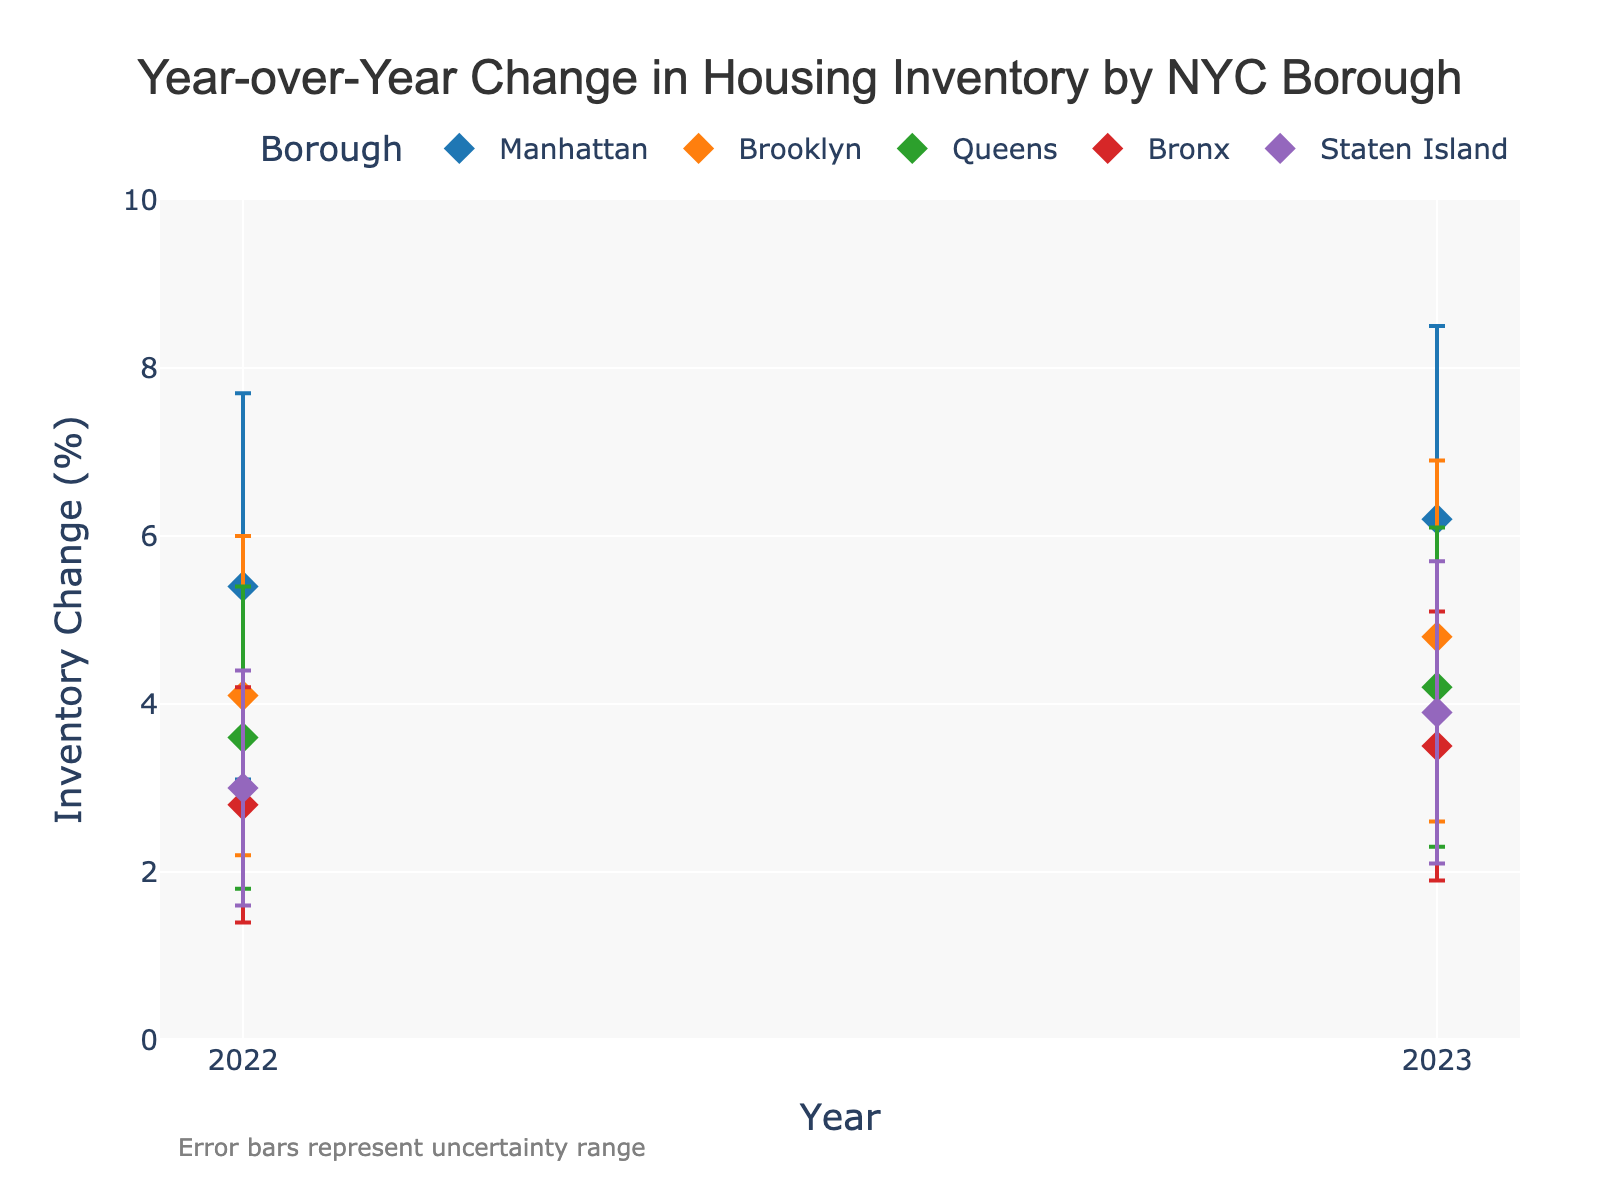What is the title of the figure? The title is located at the top of the figure. It is usually larger and bolded compared to other text elements.
Answer: Year-over-Year Change in Housing Inventory by NYC Borough Which borough had the highest mean inventory change in 2023? By looking at the y-axis values for the year 2023 markers, find the data point with the highest value.
Answer: Manhattan What is the range of inventory change for Queens in 2022? Identify the lower and upper bounds for Queens in 2022 from the error bars. The range is the difference between the upper and lower bounds.
Answer: 3.6 - 5.4 How did the mean inventory change for Brooklyn compare between 2022 and 2023? Look at the mean inventory change values for Brooklyn in both years and compare them.
Answer: Increased from 4.1 to 4.8 Which borough had the smallest error range in 2023? Calculate the error range (difference between upper and lower bounds) for each borough in 2023 and find the smallest one. For example, Bronx: 5.1 - 1.9 = 3.2, and so on for each borough.
Answer: Bronx What is the difference in mean inventory change between the Bronx and Staten Island in 2022? Compare the mean inventory change values from the dot representing the Bronx with the dot representing Staten Island in 2022. Subtract the value for Staten Island from that of the Bronx.
Answer: 2.8 - 3.0 = -0.2 Which borough shows the most significant increase in mean inventory change from 2022 to 2023? Calculate the difference in mean inventory change from 2022 to 2023 for each borough and identify the largest increase. For Manhattan: 6.2 - 5.4 = 0.8, for Brooklyn: 4.8 - 4.1 = 0.7, and so on.
Answer: Staten Island What is the average mean inventory change for Manhattan across 2022 and 2023? Add the mean inventory change values for Manhattan in both years and divide by 2.
Answer: (5.4 + 6.2) / 2 = 5.8 What is the overall trend in mean inventory change from 2022 to 2023 for all boroughs? Analyze the change in mean inventory values from 2022 to 2023 across all boroughs to determine if they generally increase, decrease, or show no consistent trend.
Answer: Increasing in all boroughs Which borough has the highest uncertainty in its inventory change in 2023? Determine the uncertainty range for all boroughs in 2023 by calculating the difference between the upper and lower bounds of the error bars. Identify the borough with the largest range. For Manhattan: 8.5 - 3.9 = 4.6, for Brooklyn: 6.9 - 2.6 = 4.3, and so on.
Answer: Manhattan 